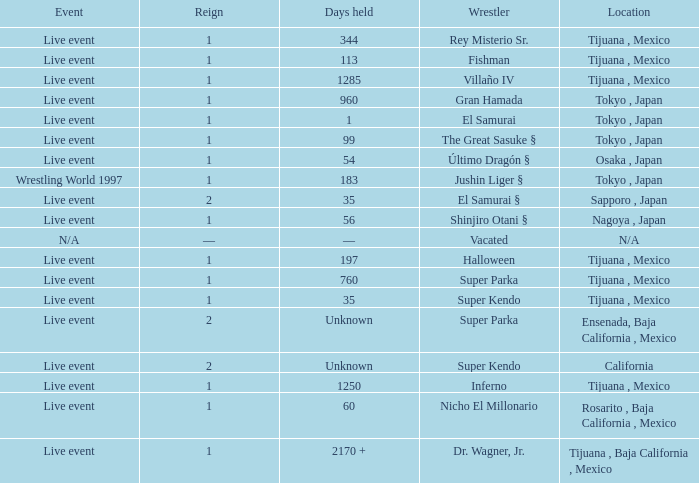Where did the wrestler, super parka, with the title with a reign of 2? Ensenada, Baja California , Mexico. 